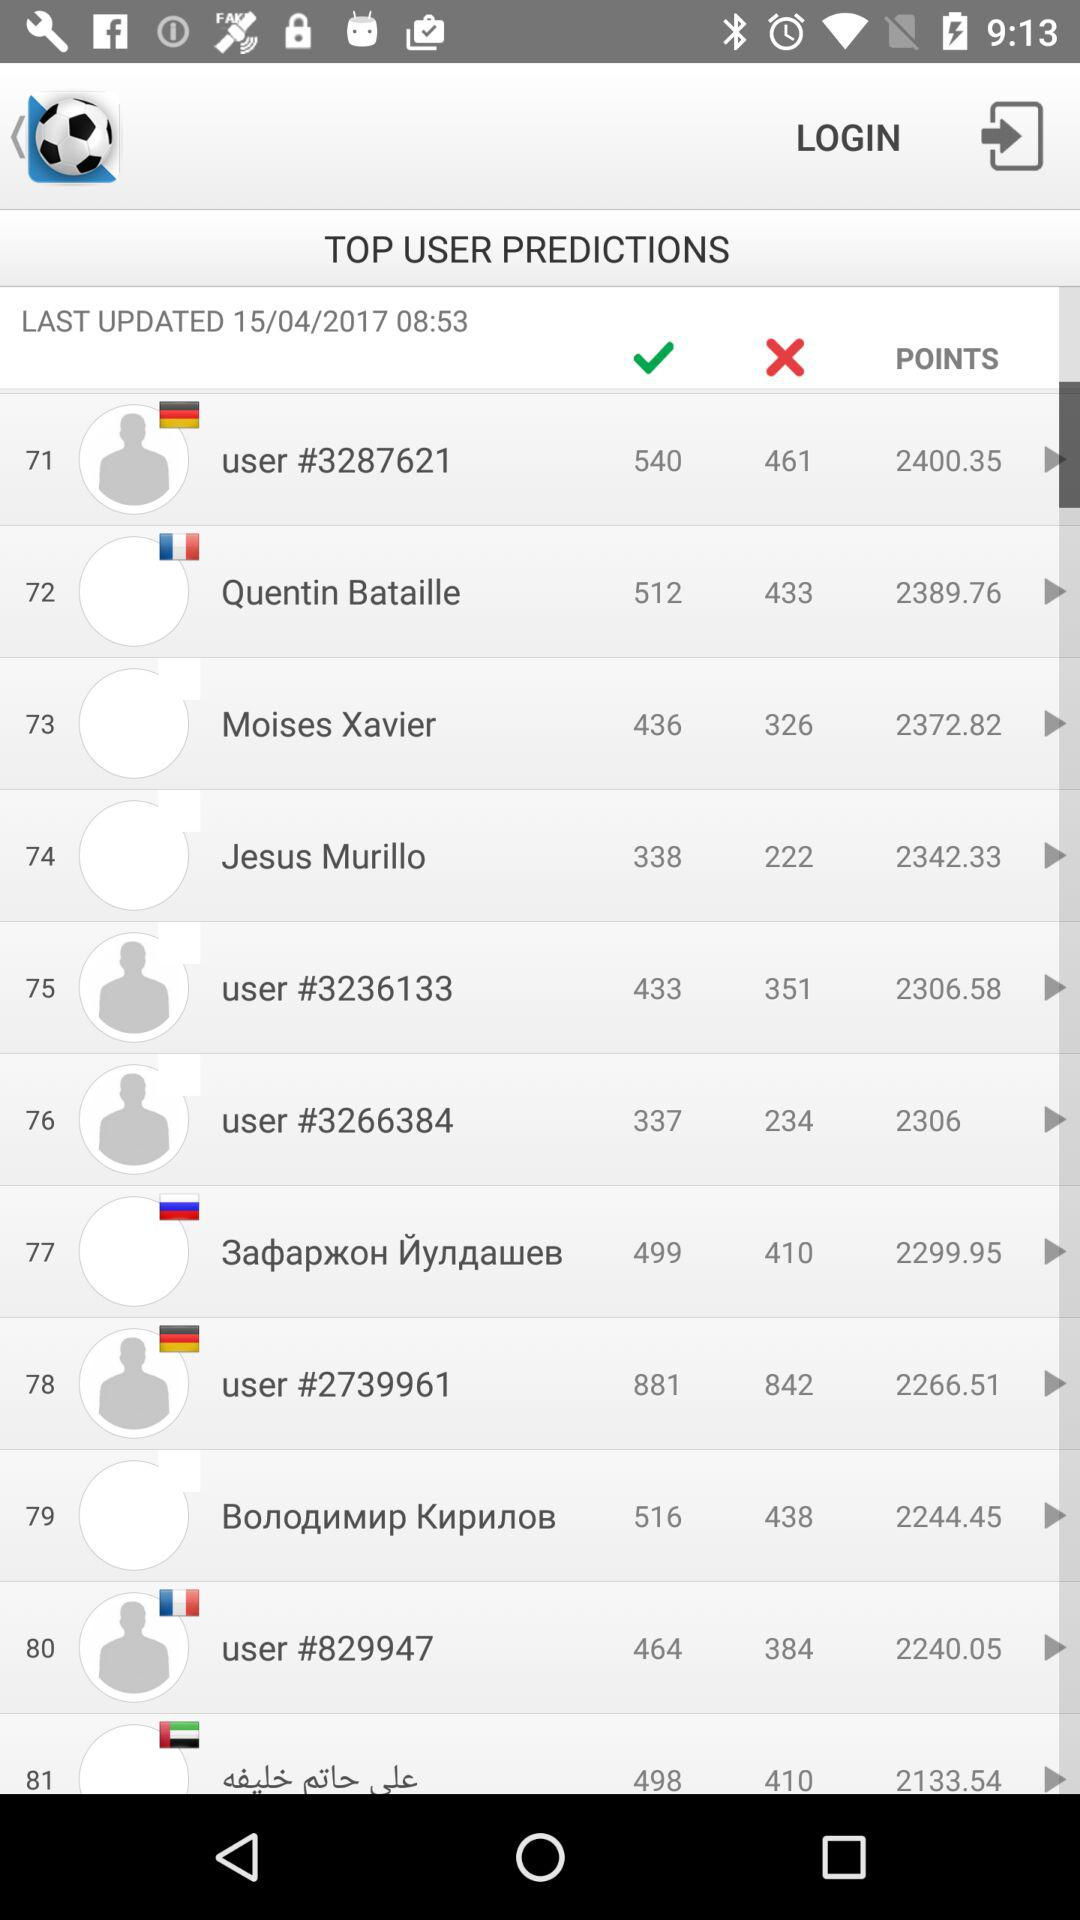What is the user name who got 2240.05 points? The name is "user #829947". 